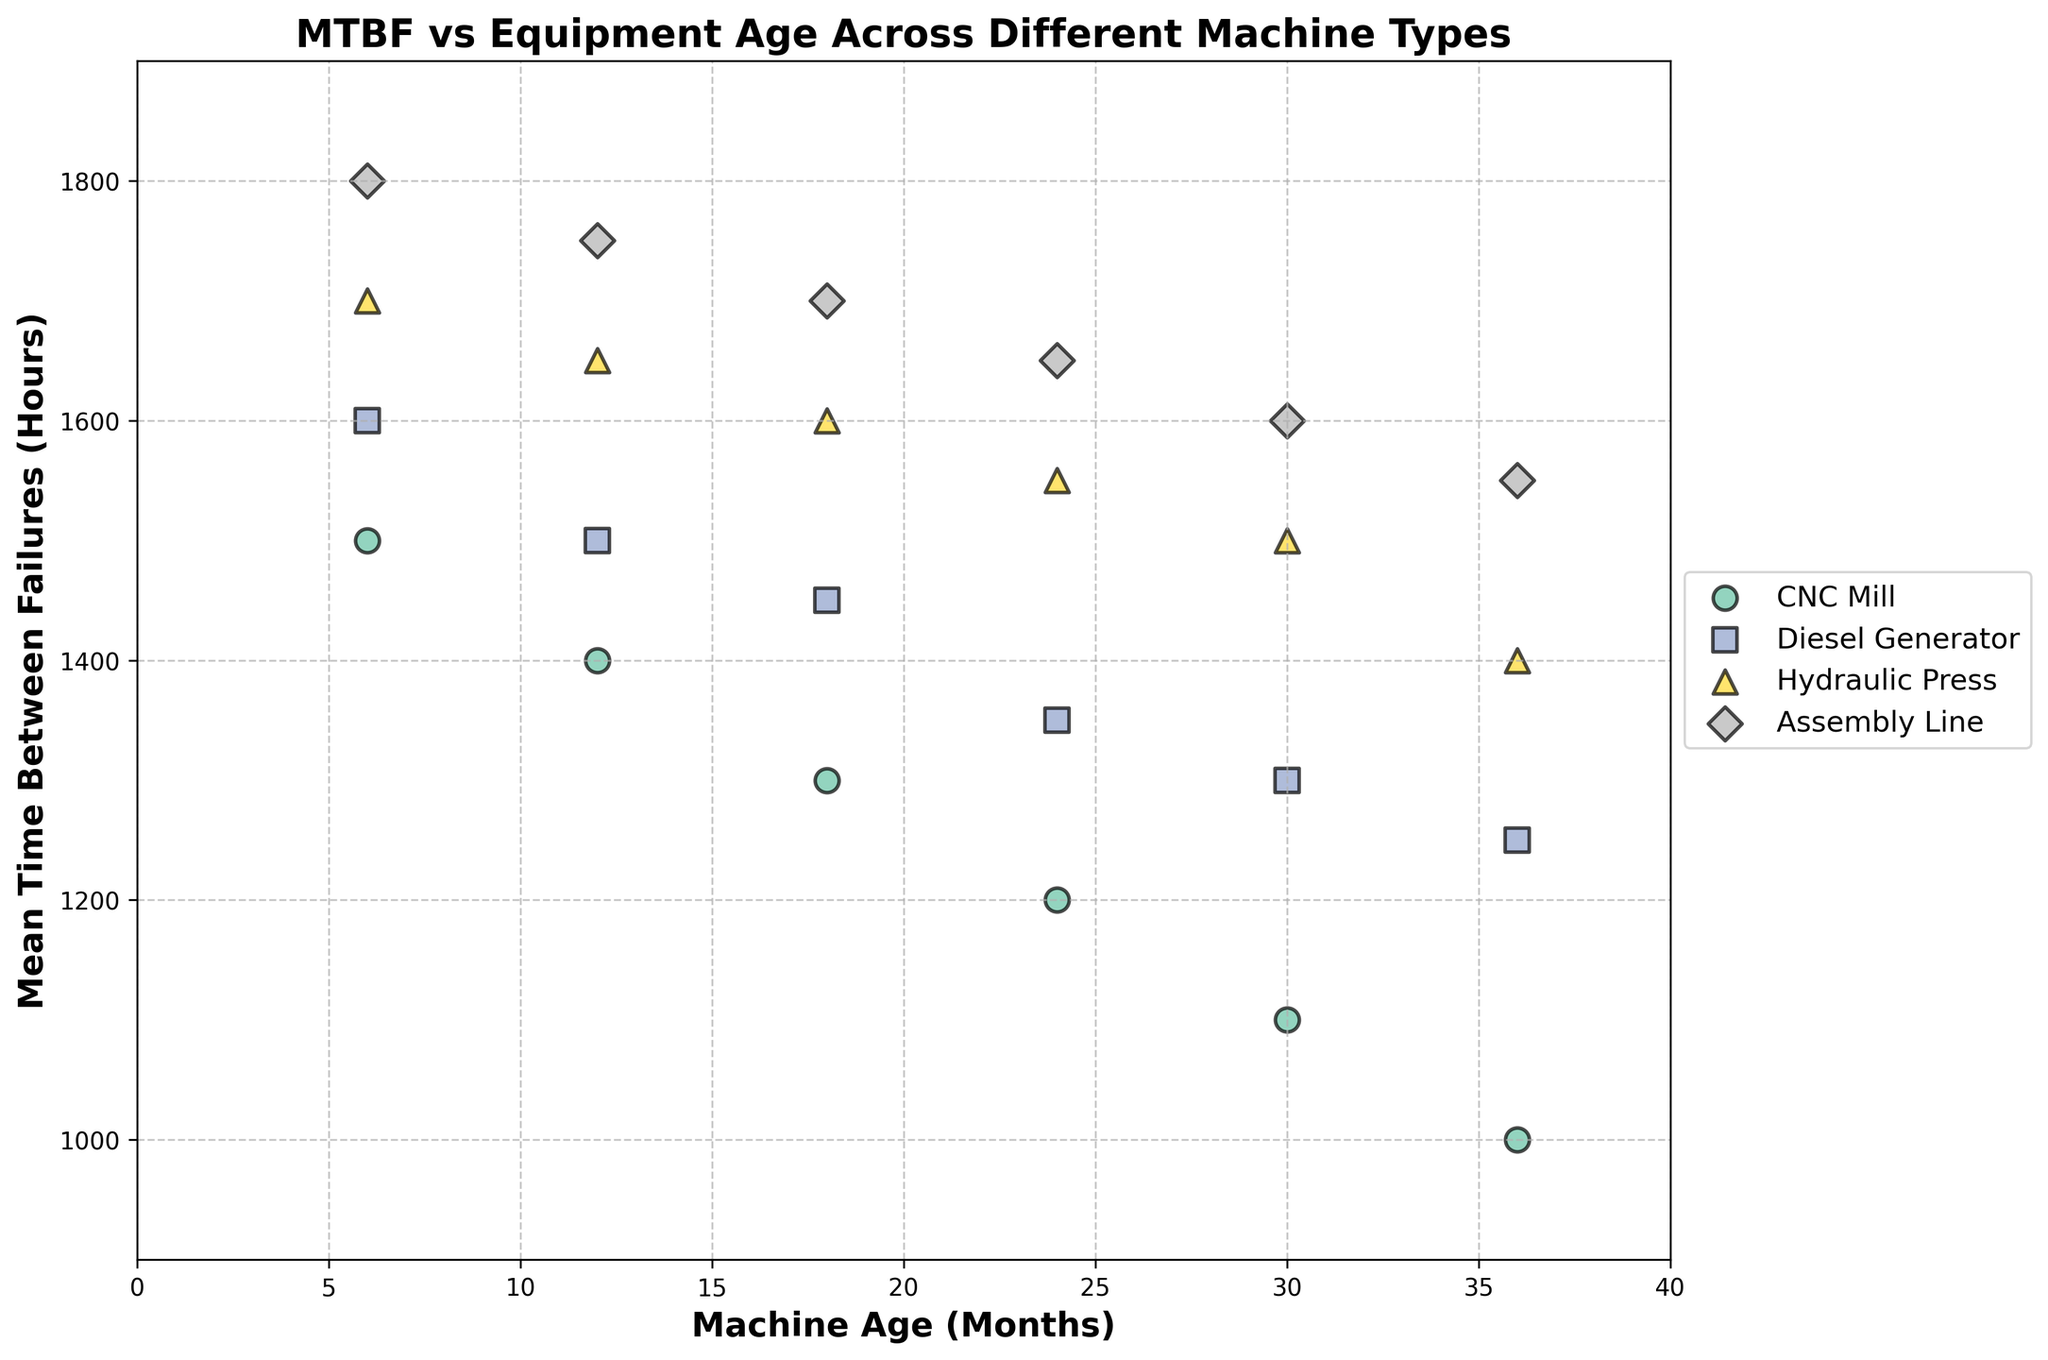What's the title of the figure? The title of the figure is written at the top in bold. It helps provide context for the data being visualized.
Answer: MTBF vs Equipment Age Across Different Machine Types Which machine type has the highest MTBF at 6 months? By examining the figure, look for the data point corresponding to 6 months on the x-axis and then identify which machine type has the highest MTBF among those points.
Answer: Assembly Line How does the MTBF of CNC_Mill change as the machine age increases from 6 months to 36 months? Observe the trend of the data points for the CNC_Mill. Identify the MTBF values at 6 months and 36 months and describe the pattern of changes.
Answer: Decreases from 1500 to 1000 hours What is the average MTBF of the Diesel_Generator across all data points in the plot? To find the average, sum all MTBF values for Diesel_Generator and divide by the number of data points (which is 6). Values are 1600, 1500, 1450, 1350, 1300, 1250. Calculate: (1600+1500+1450+1350+1300+1250)/6.
Answer: 1408.33 hours Which machine type shows the least amount of variance in MTBF across different machine ages? Check how spread out the MTBF values are across different ages for each machine type. The one with the smallest variance will have points that form the most horizontal line or cluster tightly together.
Answer: Assembly Line Compare the MTBF at 18 months between Hydraulic_Press and Diesel_Generator. Which one is higher, and by how much? Locate the data points for Hydraulic_Press and Diesel_Generator at 18 months, then compare their MTBF values directly from the plot. Hydraulic_Press is 1600, Diesel_Generator is 1450. The difference is 1600-1450.
Answer: Hydraulic_Press by 150 hours What's the general trend in MTBF as the age of equipment increases? Look at the overall direction of the data points for each machine type as the machine age on the x-axis increases. Identify whether the points move upward, downward, or remain constant.
Answer: Decreases At 24 months, which machine type has the lowest MTBF, and what is its value? Identify the data points corresponding to 24 months and find the one with the lowest MTBF value.
Answer: CNC Mill, 1200 hours How many data points are there for each machine type? Count the number of scatter points for each machine type. Since each machine has consistent data points at every 6 months interval up to 36 months.
Answer: 6 for each Which machine type maintains an MTBF value above 1500 hours the longest, and for how many months? Identify the machine type with the longest duration (months) where all MTBF values are above 1500. Assembly Line has values above 1500 up to 30 months.
Answer: Assembly Line, 30 months 